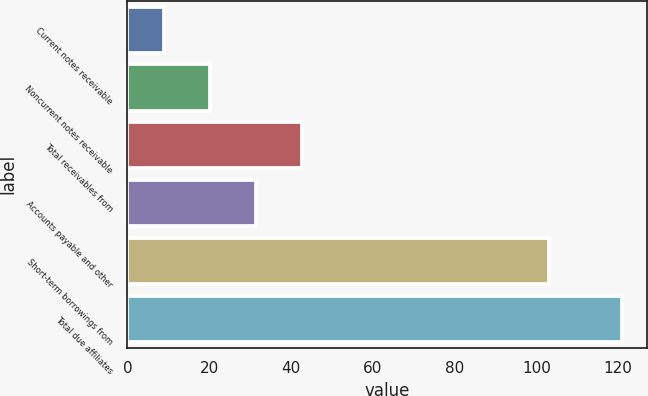Convert chart to OTSL. <chart><loc_0><loc_0><loc_500><loc_500><bar_chart><fcel>Current notes receivable<fcel>Noncurrent notes receivable<fcel>Total receivables from<fcel>Accounts payable and other<fcel>Short-term borrowings from<fcel>Total due affiliates<nl><fcel>9<fcel>20.2<fcel>42.6<fcel>31.4<fcel>103<fcel>121<nl></chart> 